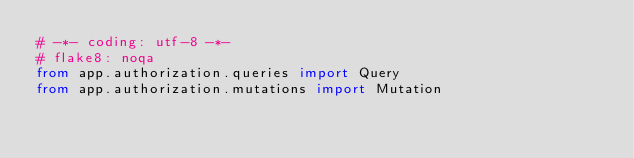<code> <loc_0><loc_0><loc_500><loc_500><_Python_># -*- coding: utf-8 -*-
# flake8: noqa
from app.authorization.queries import Query
from app.authorization.mutations import Mutation
</code> 